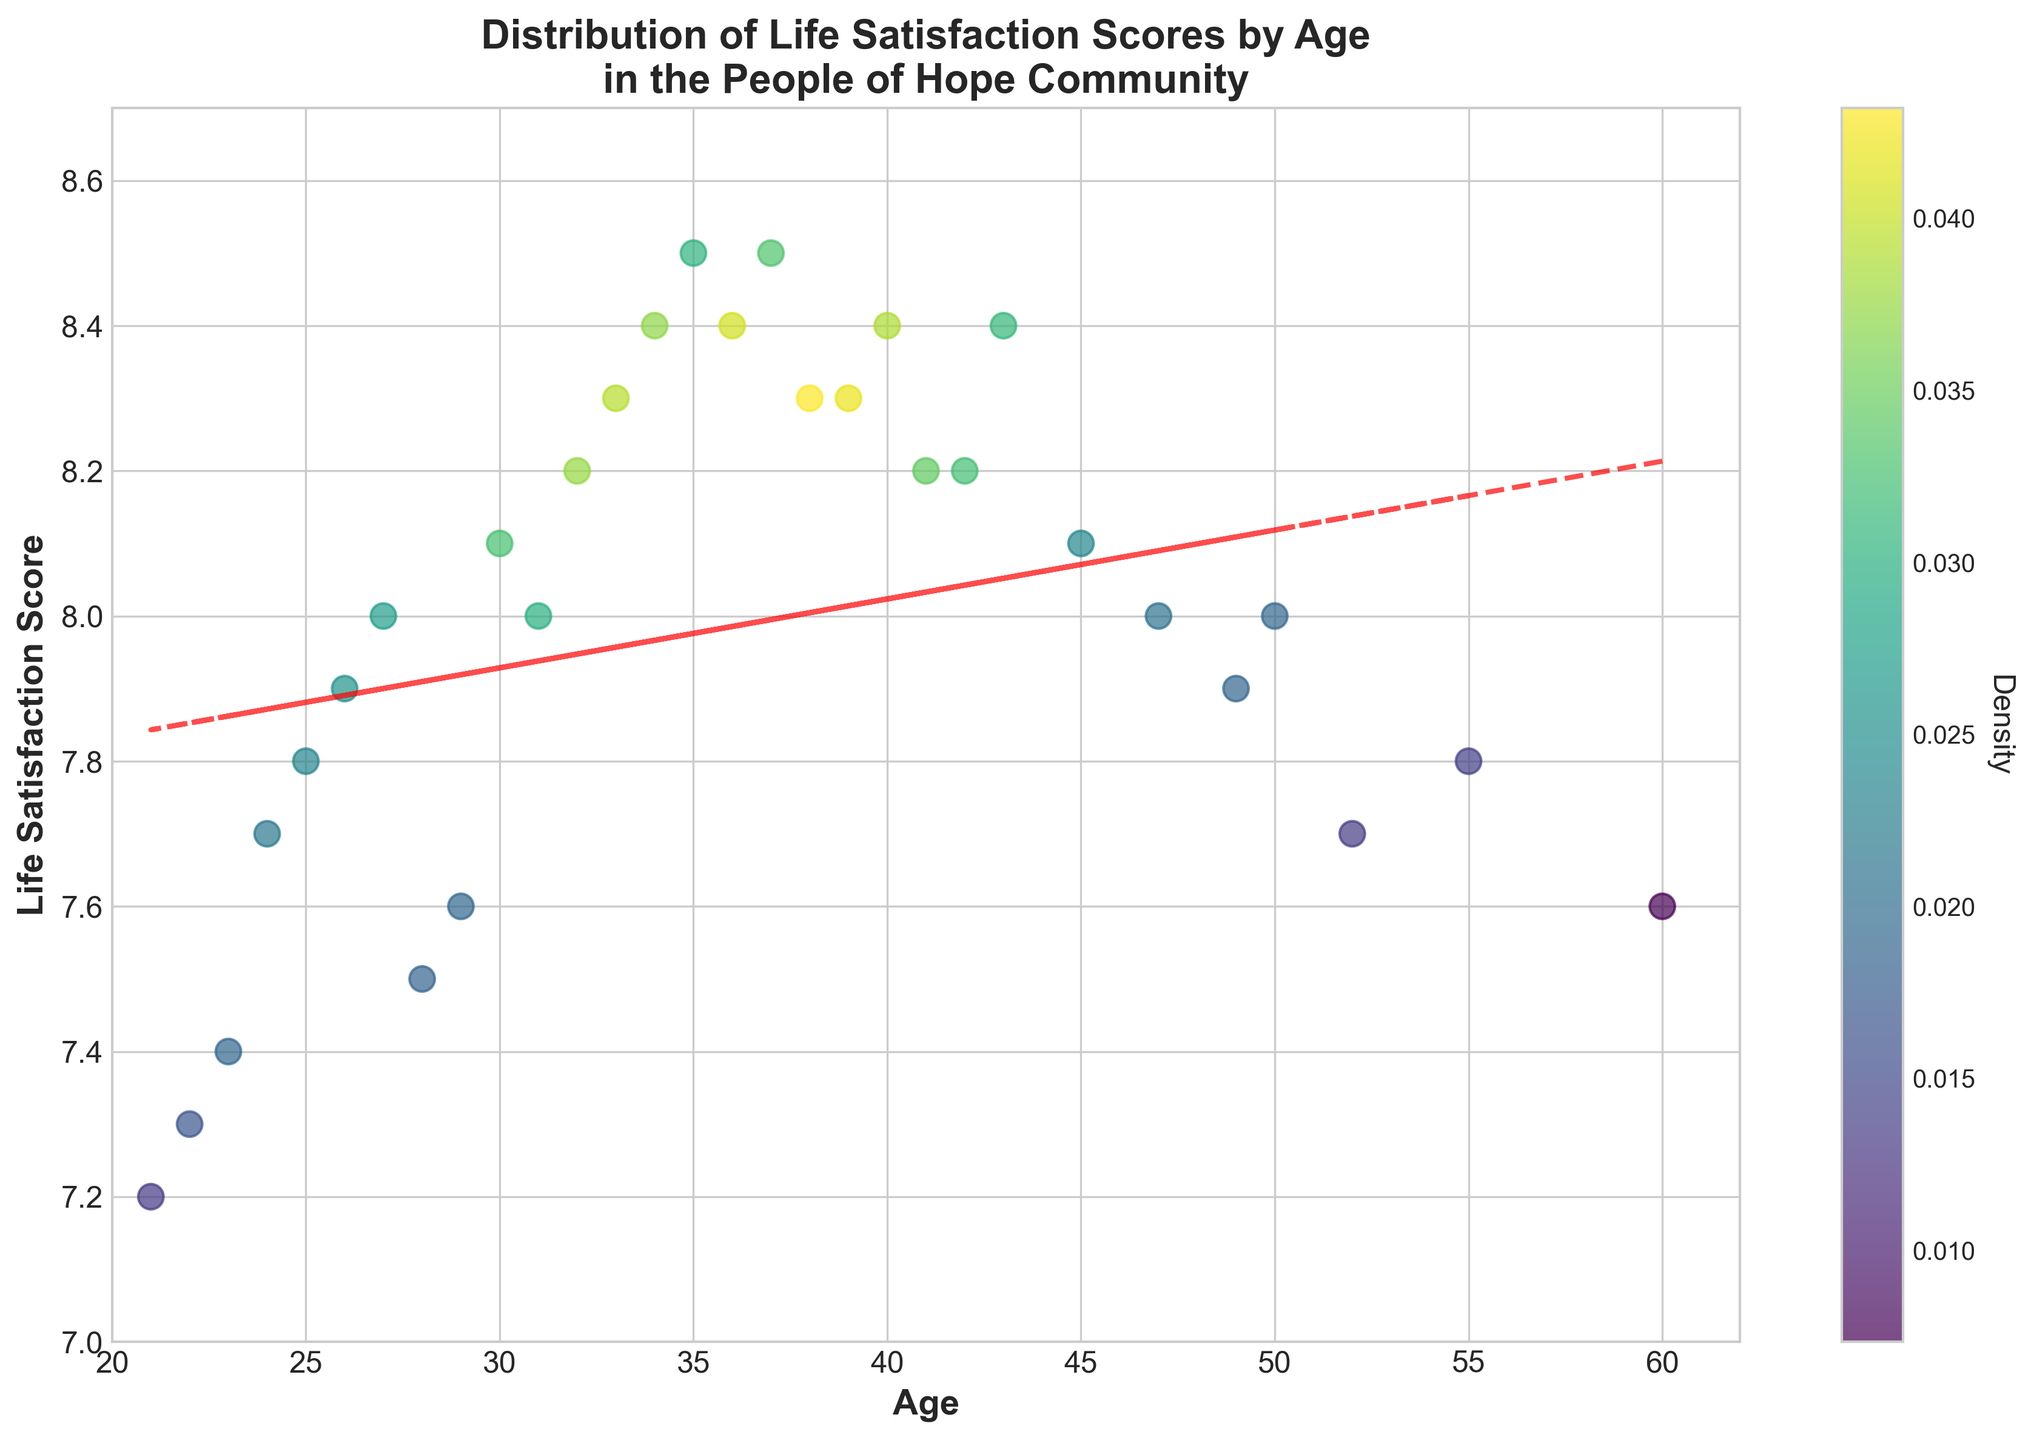What is the title of the plot? The title is the text located at the top center of the figure. In this case, it reads 'Distribution of Life Satisfaction Scores by Age in the People of Hope Community'.
Answer: Distribution of Life Satisfaction Scores by Age in the People of Hope Community What are the labels of the x and y axes? The x-axis label details the horizontal axis, while the y-axis label details the vertical axis. The x-axis is labeled 'Age' and the y-axis is labeled 'Life Satisfaction Score'.
Answer: Age and Life Satisfaction Score How does life satisfaction change with age based on the trend line? The trend line is a visual representation of the general direction of the data points. It appears that the life satisfaction score slightly increases with age. This is inferred from the slight upward slope of the red dashed trend line.
Answer: Slightly increases Between which two ages is the data most densely populated? Density can be inferred from the color intensity on the plot. The area where the data points are most concentrated has the darkest color. The data is most densely populated between the ages of 25 and 40.
Answer: Between 25 and 40 What is the lowest life satisfaction score in the plot? The lowest life satisfaction score can be found by looking at the minimum value on the y-axis of the plot. This score is around 7.2.
Answer: 7.2 Which age group has the highest concentration of life satisfaction scores above 8.0? Observing the scatter plot, the most densely colored areas above a life satisfaction score of 8.0 are clustered between the ages of 30 and 40.
Answer: 30 to 40 What is the average life satisfaction score for ages 30 to 40? To find the average, identify the life satisfaction scores for ages between 30 and 40, sum them up, and divide by the number of data points. Scores are 8.1, 8.0, 8.2, 8.3, 8.2, 8.4, 8.0, 7.9, 8.3. Average = (8.1+8.0+8.2+8.3+8.2+8.4+8.0+7.9+8.3)/9 = 72.4/9 = 8.04
Answer: 8.04 How many age groups have life satisfaction scores below 7.5? Scan the scatter plot for data points below the 7.5 mark on the y-axis. There are data points at ages 21, 22, and 23.
Answer: 3 Is there a point on the plot with an age of 50? What is its life satisfaction score? Locate the point on the x-axis corresponding to age 50 and track it vertically to the data point, revealing a life satisfaction score of 8.0.
Answer: 8.0 Which age has the highest life satisfaction score, and what is that score? Scan the scatter plot to find the highest point on the y-axis. The ages 35, 37, and 38 all have the highest life satisfaction score of 8.5.
Answer: Ages 35, 37, and 38 with a score of 8.5 